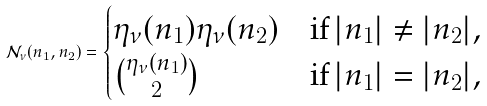Convert formula to latex. <formula><loc_0><loc_0><loc_500><loc_500>\mathcal { N } _ { \nu } ( n _ { 1 } , n _ { 2 } ) = \begin{cases} \eta _ { \nu } ( n _ { 1 } ) \eta _ { \nu } ( n _ { 2 } ) & \text {if} \, | n _ { 1 } | \neq | n _ { 2 } | , \\ \binom { \eta _ { \nu } ( n _ { 1 } ) } { 2 } & \text {if} \, | n _ { 1 } | = | n _ { 2 } | , \end{cases}</formula> 